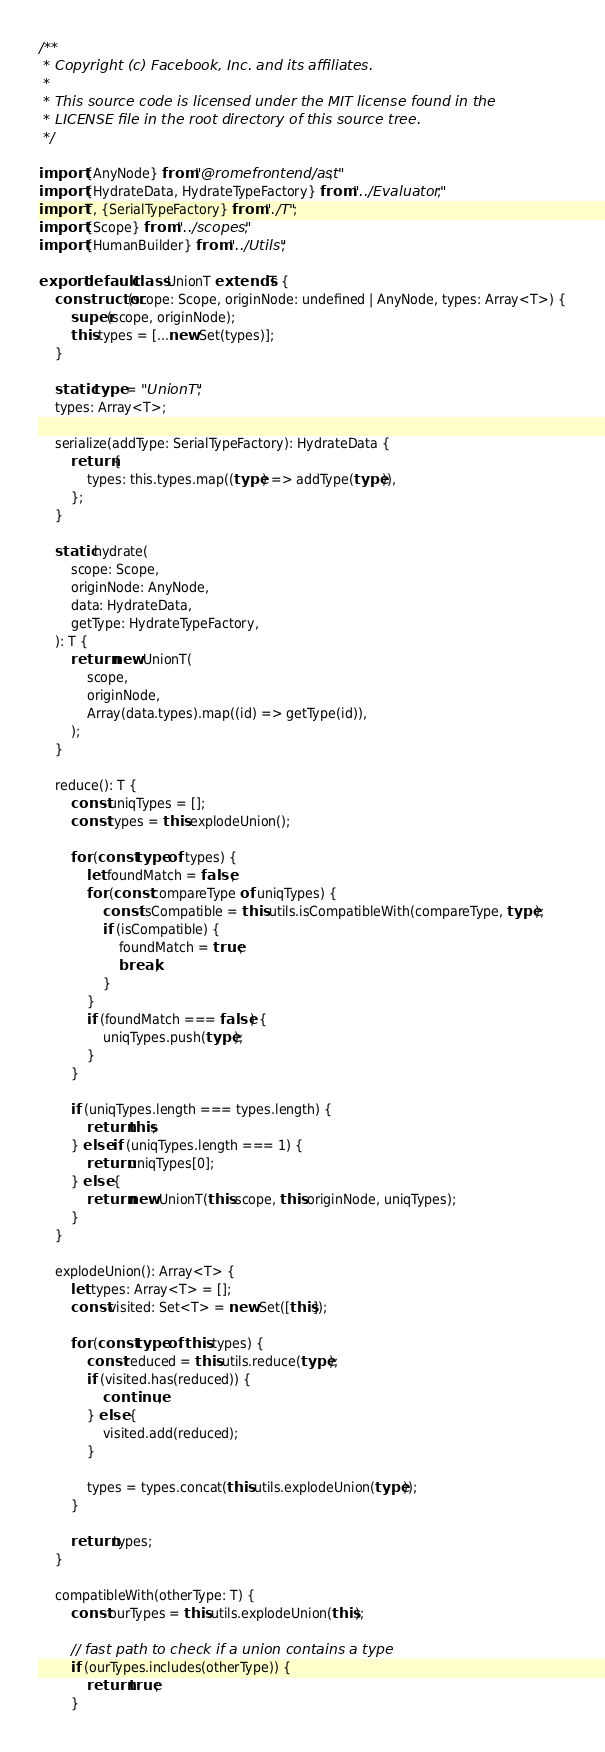Convert code to text. <code><loc_0><loc_0><loc_500><loc_500><_TypeScript_>/**
 * Copyright (c) Facebook, Inc. and its affiliates.
 *
 * This source code is licensed under the MIT license found in the
 * LICENSE file in the root directory of this source tree.
 */

import {AnyNode} from "@romefrontend/ast";
import {HydrateData, HydrateTypeFactory} from "../Evaluator";
import T, {SerialTypeFactory} from "./T";
import {Scope} from "../scopes";
import {HumanBuilder} from "../Utils";

export default class UnionT extends T {
	constructor(scope: Scope, originNode: undefined | AnyNode, types: Array<T>) {
		super(scope, originNode);
		this.types = [...new Set(types)];
	}

	static type = "UnionT";
	types: Array<T>;

	serialize(addType: SerialTypeFactory): HydrateData {
		return {
			types: this.types.map((type) => addType(type)),
		};
	}

	static hydrate(
		scope: Scope,
		originNode: AnyNode,
		data: HydrateData,
		getType: HydrateTypeFactory,
	): T {
		return new UnionT(
			scope,
			originNode,
			Array(data.types).map((id) => getType(id)),
		);
	}

	reduce(): T {
		const uniqTypes = [];
		const types = this.explodeUnion();

		for (const type of types) {
			let foundMatch = false;
			for (const compareType of uniqTypes) {
				const isCompatible = this.utils.isCompatibleWith(compareType, type);
				if (isCompatible) {
					foundMatch = true;
					break;
				}
			}
			if (foundMatch === false) {
				uniqTypes.push(type);
			}
		}

		if (uniqTypes.length === types.length) {
			return this;
		} else if (uniqTypes.length === 1) {
			return uniqTypes[0];
		} else {
			return new UnionT(this.scope, this.originNode, uniqTypes);
		}
	}

	explodeUnion(): Array<T> {
		let types: Array<T> = [];
		const visited: Set<T> = new Set([this]);

		for (const type of this.types) {
			const reduced = this.utils.reduce(type);
			if (visited.has(reduced)) {
				continue;
			} else {
				visited.add(reduced);
			}

			types = types.concat(this.utils.explodeUnion(type));
		}

		return types;
	}

	compatibleWith(otherType: T) {
		const ourTypes = this.utils.explodeUnion(this);

		// fast path to check if a union contains a type
		if (ourTypes.includes(otherType)) {
			return true;
		}
</code> 